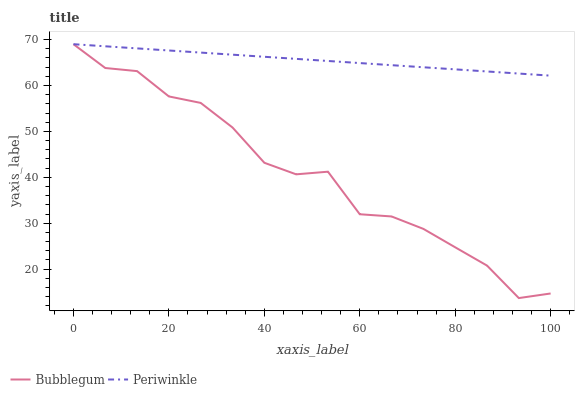Does Bubblegum have the minimum area under the curve?
Answer yes or no. Yes. Does Periwinkle have the maximum area under the curve?
Answer yes or no. Yes. Does Bubblegum have the maximum area under the curve?
Answer yes or no. No. Is Periwinkle the smoothest?
Answer yes or no. Yes. Is Bubblegum the roughest?
Answer yes or no. Yes. Is Bubblegum the smoothest?
Answer yes or no. No. Does Bubblegum have the lowest value?
Answer yes or no. Yes. Does Bubblegum have the highest value?
Answer yes or no. Yes. Does Periwinkle intersect Bubblegum?
Answer yes or no. Yes. Is Periwinkle less than Bubblegum?
Answer yes or no. No. Is Periwinkle greater than Bubblegum?
Answer yes or no. No. 